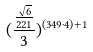<formula> <loc_0><loc_0><loc_500><loc_500>( \frac { \frac { \sqrt { 6 } } { 2 2 1 } } { 3 } ) ^ { ( 3 4 9 \cdot 4 ) + 1 }</formula> 